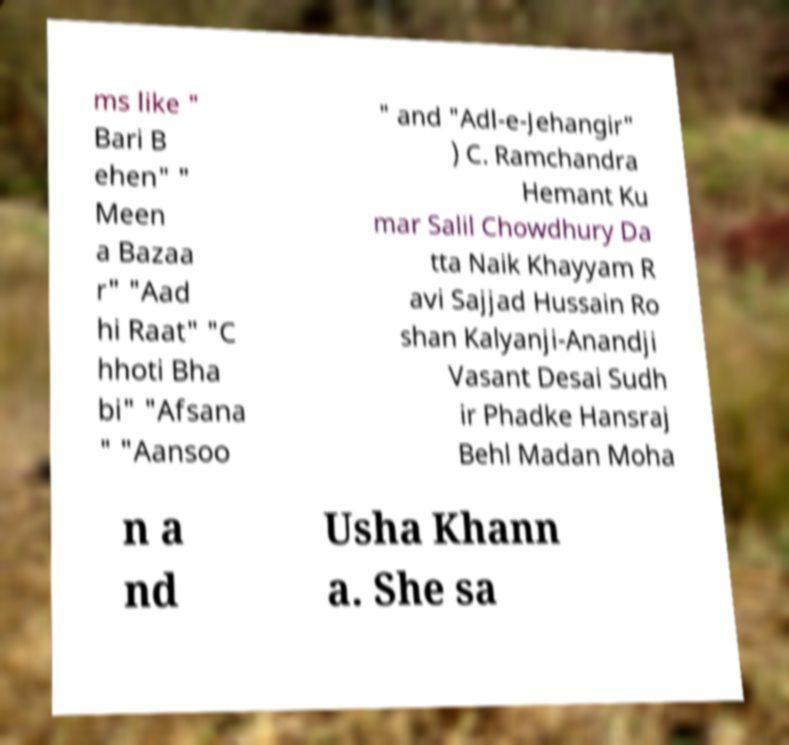Please identify and transcribe the text found in this image. ms like " Bari B ehen" " Meen a Bazaa r" "Aad hi Raat" "C hhoti Bha bi" "Afsana " "Aansoo " and "Adl-e-Jehangir" ) C. Ramchandra Hemant Ku mar Salil Chowdhury Da tta Naik Khayyam R avi Sajjad Hussain Ro shan Kalyanji-Anandji Vasant Desai Sudh ir Phadke Hansraj Behl Madan Moha n a nd Usha Khann a. She sa 